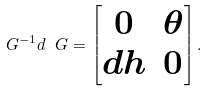Convert formula to latex. <formula><loc_0><loc_0><loc_500><loc_500>\ G ^ { - 1 } d \ G = \begin{bmatrix} 0 & \theta \\ d h & 0 \end{bmatrix} .</formula> 